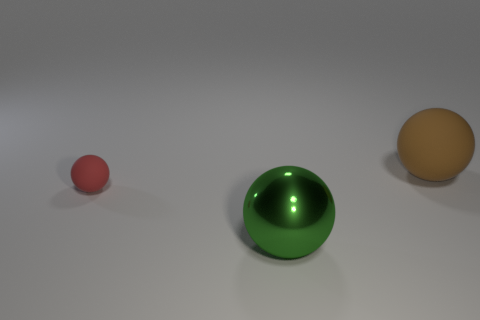Subtract 1 balls. How many balls are left? 2 Add 3 green objects. How many objects exist? 6 Add 2 small rubber things. How many small rubber things are left? 3 Add 2 yellow cylinders. How many yellow cylinders exist? 2 Subtract 0 yellow cubes. How many objects are left? 3 Subtract all tiny brown metallic objects. Subtract all big brown things. How many objects are left? 2 